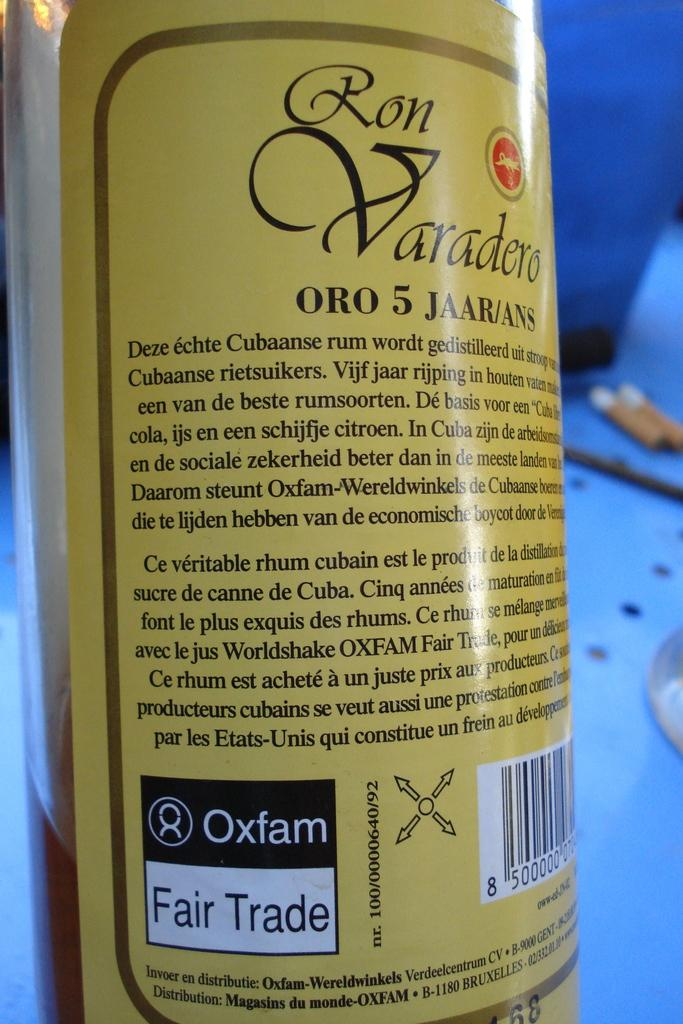<image>
Describe the image concisely. The back label of a bottle of Ron Varadero rum that is a fair trade product. 